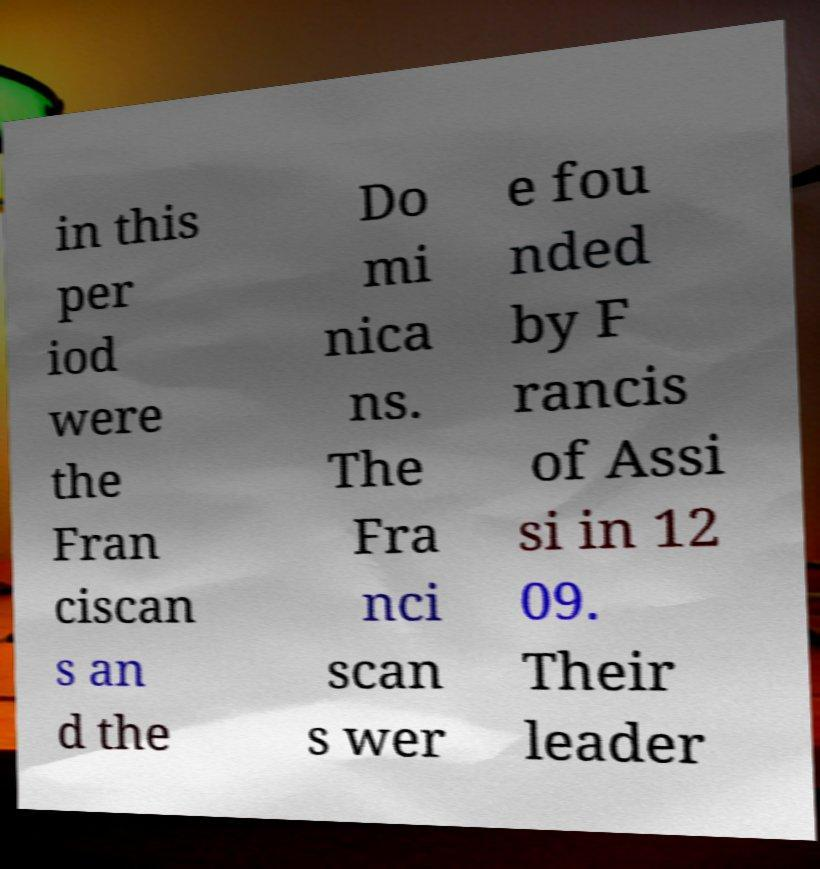What messages or text are displayed in this image? I need them in a readable, typed format. in this per iod were the Fran ciscan s an d the Do mi nica ns. The Fra nci scan s wer e fou nded by F rancis of Assi si in 12 09. Their leader 